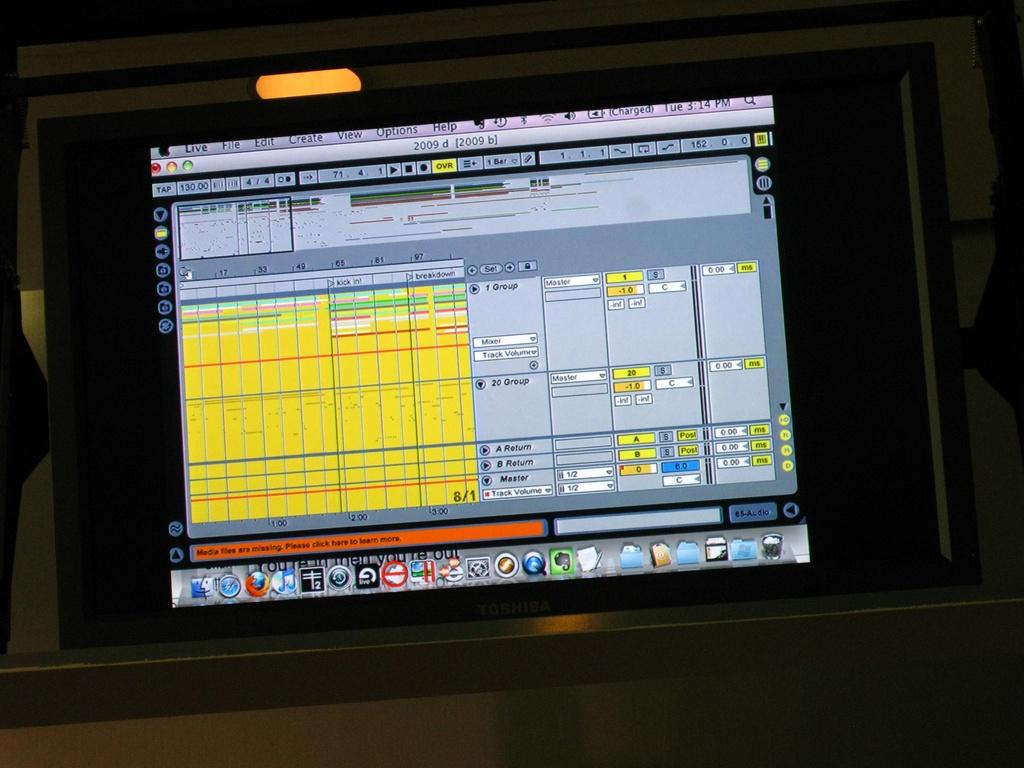<image>
Relay a brief, clear account of the picture shown. Toshiba computer monitor with a screen that says "Live" on the top left. 